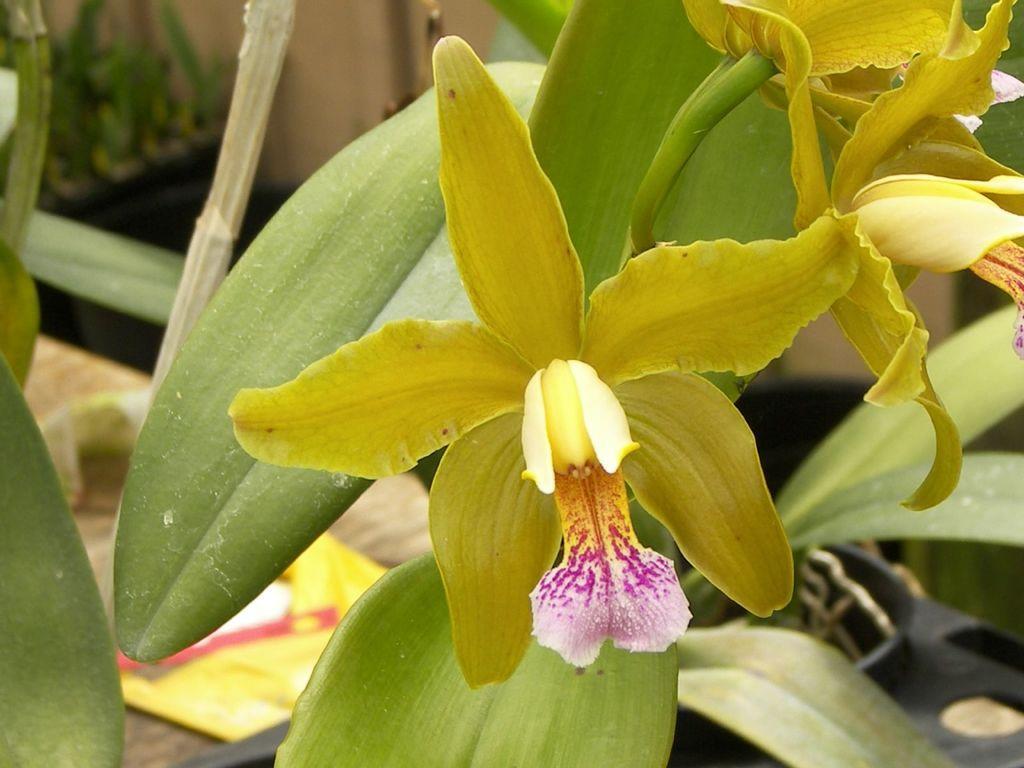How would you summarize this image in a sentence or two? In this image we can see flowers and leaves. 